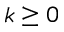Convert formula to latex. <formula><loc_0><loc_0><loc_500><loc_500>k \geq 0</formula> 